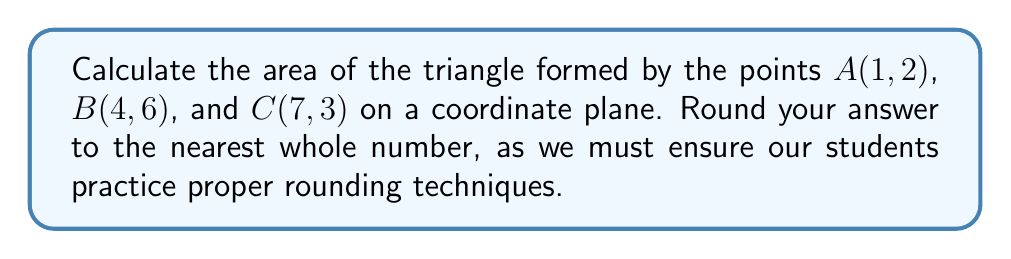Help me with this question. To calculate the area of a triangle given three points on a coordinate plane, we can use the following formula:

$$\text{Area} = \frac{1}{2}|x_1(y_2 - y_3) + x_2(y_3 - y_1) + x_3(y_1 - y_2)|$$

Where $(x_1, y_1)$, $(x_2, y_2)$, and $(x_3, y_3)$ are the coordinates of the three points.

Step 1: Identify the coordinates
$A(x_1, y_1) = (1, 2)$
$B(x_2, y_2) = (4, 6)$
$C(x_3, y_3) = (7, 3)$

Step 2: Substitute the values into the formula
$$\text{Area} = \frac{1}{2}|1(6 - 3) + 4(3 - 2) + 7(2 - 6)|$$

Step 3: Simplify the expression inside the absolute value bars
$$\text{Area} = \frac{1}{2}|1(3) + 4(1) + 7(-4)|$$
$$\text{Area} = \frac{1}{2}|3 + 4 - 28|$$
$$\text{Area} = \frac{1}{2}|-21|$$

Step 4: Calculate the absolute value
$$\text{Area} = \frac{1}{2}(21)$$

Step 5: Perform the final calculation
$$\text{Area} = 10.5$$

Step 6: Round to the nearest whole number
$$\text{Area} \approx 11$$
Answer: 11 square units 